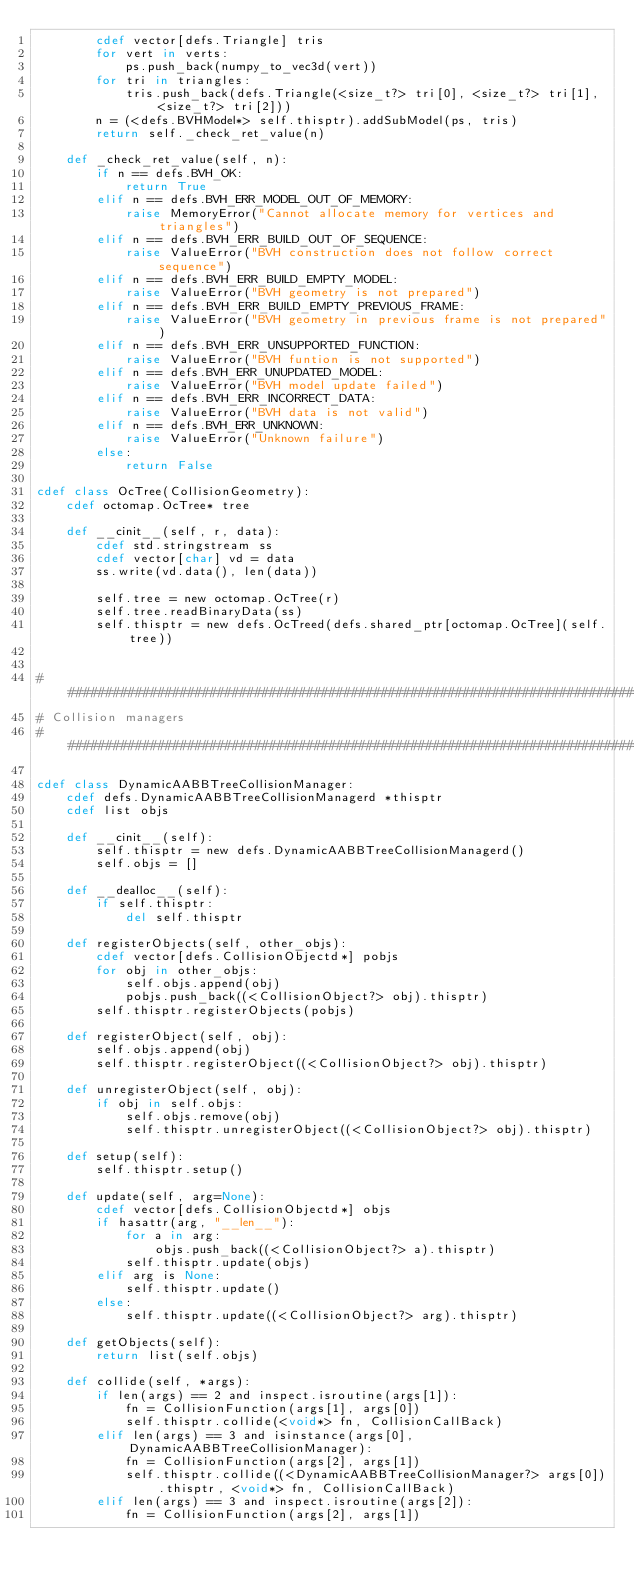Convert code to text. <code><loc_0><loc_0><loc_500><loc_500><_Cython_>        cdef vector[defs.Triangle] tris
        for vert in verts:
            ps.push_back(numpy_to_vec3d(vert))
        for tri in triangles:
            tris.push_back(defs.Triangle(<size_t?> tri[0], <size_t?> tri[1], <size_t?> tri[2]))
        n = (<defs.BVHModel*> self.thisptr).addSubModel(ps, tris)
        return self._check_ret_value(n)

    def _check_ret_value(self, n):
        if n == defs.BVH_OK:
            return True
        elif n == defs.BVH_ERR_MODEL_OUT_OF_MEMORY:
            raise MemoryError("Cannot allocate memory for vertices and triangles")
        elif n == defs.BVH_ERR_BUILD_OUT_OF_SEQUENCE:
            raise ValueError("BVH construction does not follow correct sequence")
        elif n == defs.BVH_ERR_BUILD_EMPTY_MODEL:
            raise ValueError("BVH geometry is not prepared")
        elif n == defs.BVH_ERR_BUILD_EMPTY_PREVIOUS_FRAME:
            raise ValueError("BVH geometry in previous frame is not prepared")
        elif n == defs.BVH_ERR_UNSUPPORTED_FUNCTION:
            raise ValueError("BVH funtion is not supported")
        elif n == defs.BVH_ERR_UNUPDATED_MODEL:
            raise ValueError("BVH model update failed")
        elif n == defs.BVH_ERR_INCORRECT_DATA:
            raise ValueError("BVH data is not valid")
        elif n == defs.BVH_ERR_UNKNOWN:
            raise ValueError("Unknown failure")
        else:
            return False

cdef class OcTree(CollisionGeometry):
    cdef octomap.OcTree* tree

    def __cinit__(self, r, data):
        cdef std.stringstream ss
        cdef vector[char] vd = data
        ss.write(vd.data(), len(data))

        self.tree = new octomap.OcTree(r) 
        self.tree.readBinaryData(ss)
        self.thisptr = new defs.OcTreed(defs.shared_ptr[octomap.OcTree](self.tree))


###############################################################################
# Collision managers
###############################################################################

cdef class DynamicAABBTreeCollisionManager:
    cdef defs.DynamicAABBTreeCollisionManagerd *thisptr
    cdef list objs

    def __cinit__(self):
        self.thisptr = new defs.DynamicAABBTreeCollisionManagerd()
        self.objs = []

    def __dealloc__(self):
        if self.thisptr:
            del self.thisptr

    def registerObjects(self, other_objs):
        cdef vector[defs.CollisionObjectd*] pobjs
        for obj in other_objs:
            self.objs.append(obj)
            pobjs.push_back((<CollisionObject?> obj).thisptr)
        self.thisptr.registerObjects(pobjs)

    def registerObject(self, obj):
        self.objs.append(obj)
        self.thisptr.registerObject((<CollisionObject?> obj).thisptr)

    def unregisterObject(self, obj):
        if obj in self.objs:
            self.objs.remove(obj)
            self.thisptr.unregisterObject((<CollisionObject?> obj).thisptr)

    def setup(self):
        self.thisptr.setup()

    def update(self, arg=None):
        cdef vector[defs.CollisionObjectd*] objs
        if hasattr(arg, "__len__"):
            for a in arg:
                objs.push_back((<CollisionObject?> a).thisptr)
            self.thisptr.update(objs)
        elif arg is None:
            self.thisptr.update()
        else:
            self.thisptr.update((<CollisionObject?> arg).thisptr)

    def getObjects(self):
        return list(self.objs)

    def collide(self, *args):
        if len(args) == 2 and inspect.isroutine(args[1]):
            fn = CollisionFunction(args[1], args[0])
            self.thisptr.collide(<void*> fn, CollisionCallBack)
        elif len(args) == 3 and isinstance(args[0], DynamicAABBTreeCollisionManager):
            fn = CollisionFunction(args[2], args[1])
            self.thisptr.collide((<DynamicAABBTreeCollisionManager?> args[0]).thisptr, <void*> fn, CollisionCallBack)
        elif len(args) == 3 and inspect.isroutine(args[2]):
            fn = CollisionFunction(args[2], args[1])</code> 